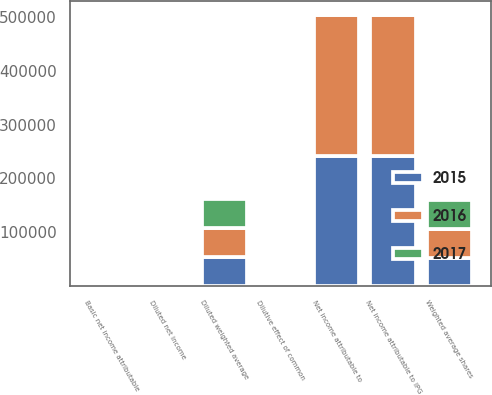Convert chart to OTSL. <chart><loc_0><loc_0><loc_500><loc_500><stacked_bar_chart><ecel><fcel>Net income attributable to IPG<fcel>Net income attributable to<fcel>Weighted average shares<fcel>Dilutive effect of common<fcel>Diluted weighted average<fcel>Basic net income attributable<fcel>Diluted net income<nl><fcel>2017<fcel>977.5<fcel>977.5<fcel>53495<fcel>1204<fcel>54699<fcel>6.5<fcel>6.36<nl><fcel>2016<fcel>260752<fcel>260752<fcel>53068<fcel>729<fcel>53797<fcel>4.91<fcel>4.85<nl><fcel>2015<fcel>242154<fcel>242154<fcel>52676<fcel>751<fcel>53427<fcel>4.6<fcel>4.53<nl></chart> 